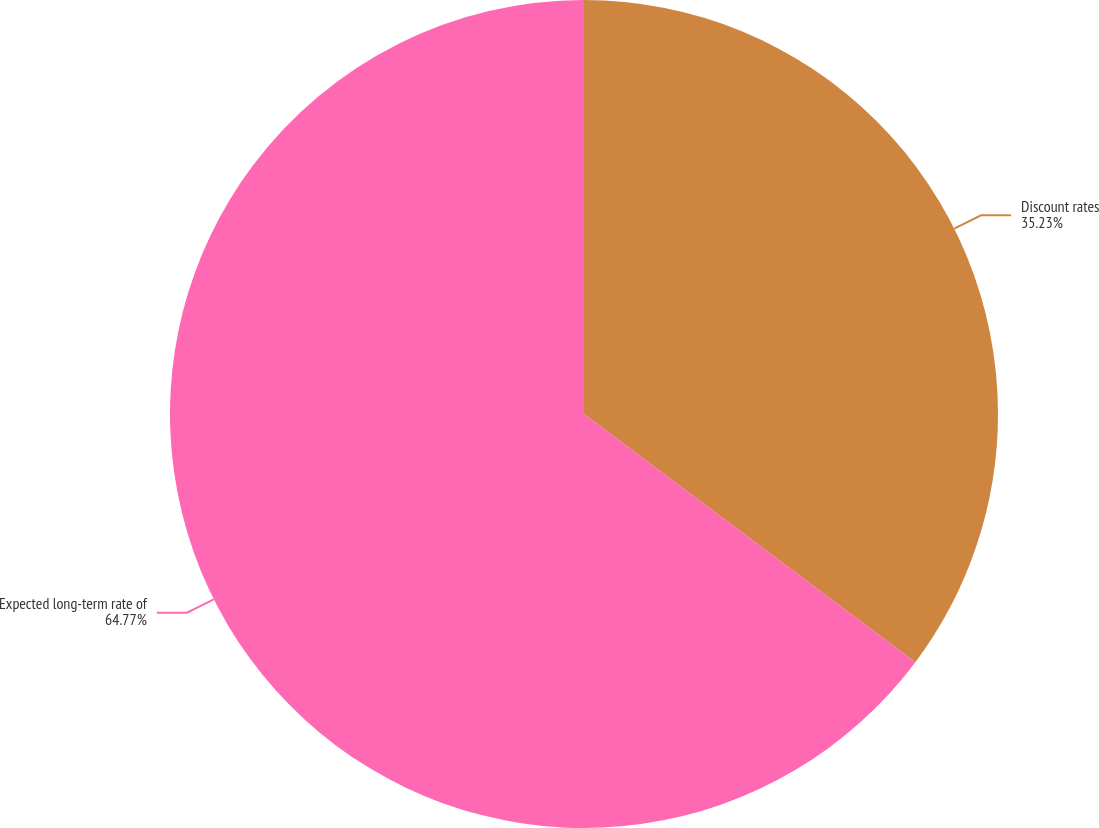<chart> <loc_0><loc_0><loc_500><loc_500><pie_chart><fcel>Discount rates<fcel>Expected long-term rate of<nl><fcel>35.23%<fcel>64.77%<nl></chart> 